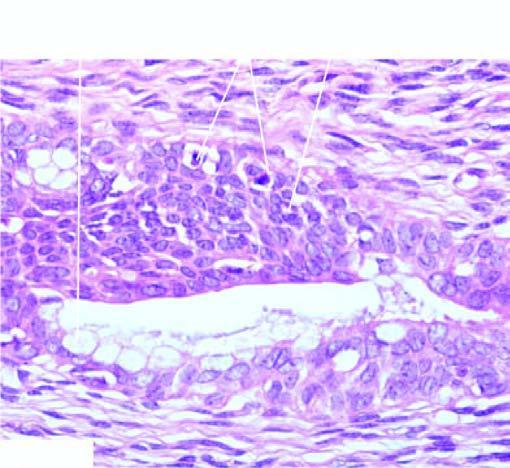have these cells marked cytologic atypia including mitoses?
Answer the question using a single word or phrase. No 